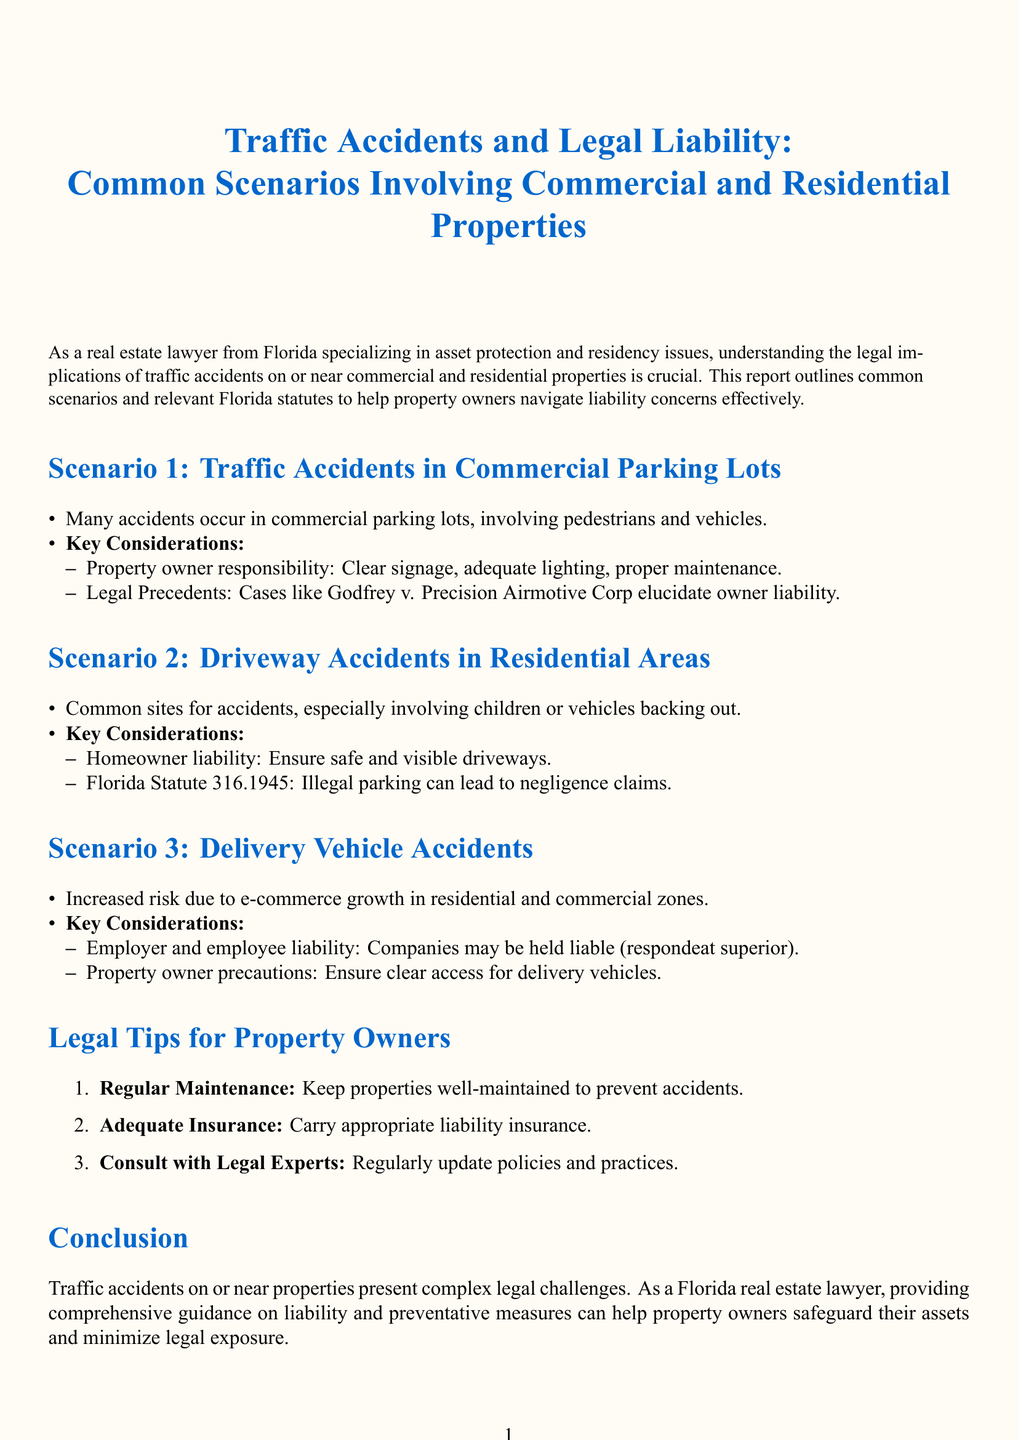What is the title of the report? The title is given in a formatted manner at the beginning of the document and highlights the subject matter, which is about traffic accidents and legal liability.
Answer: Traffic Accidents and Legal Liability: Common Scenarios Involving Commercial and Residential Properties What Florida statute is mentioned regarding driveway accidents? The document specifies a statute related to illegal parking that can lead to negligence claims concerning driveway accidents.
Answer: Florida Statute 316.1945 What is one key consideration for traffic accidents in commercial parking lots? The document lists critical factors for property owners concerning commercial parking lots, highlighting responsibilities to prevent accidents.
Answer: Clear signage What is a common risk associated with delivery vehicle accidents? The document addresses the increased risk due to the rise of e-commerce and its implications for property owners and potential liabilities.
Answer: E-commerce growth How many key legal tips for property owners are provided in the report? The report outlines essential advice for property owners to help minimize legal exposure concerning traffic accidents.
Answer: Three What does "respondeat superior" pertain to in the context of the report? This term is mentioned in relation to the legal concept whereby employers may be held liable for the actions of their employees during the course of employment, particularly concerning delivery vehicle accidents.
Answer: Liability What is one action property owners should take according to legal tips? The document outlines maintenance as an essential proactive measure to prevent accidents on properties.
Answer: Regular Maintenance 